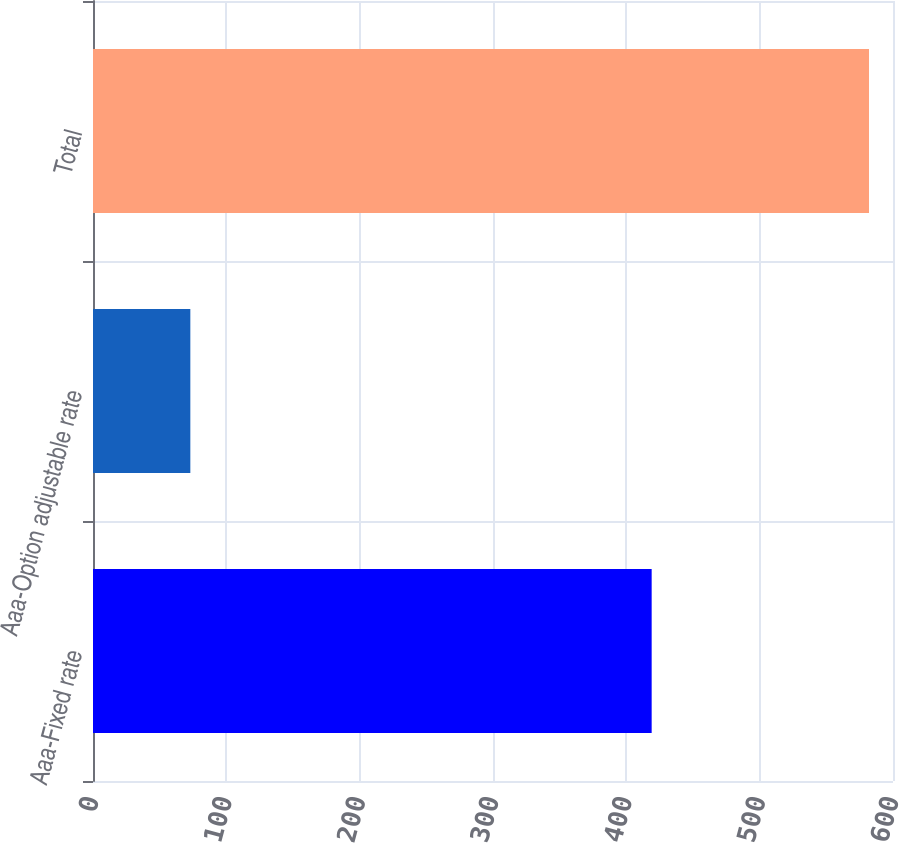Convert chart. <chart><loc_0><loc_0><loc_500><loc_500><bar_chart><fcel>Aaa-Fixed rate<fcel>Aaa-Option adjustable rate<fcel>Total<nl><fcel>419<fcel>73<fcel>582<nl></chart> 